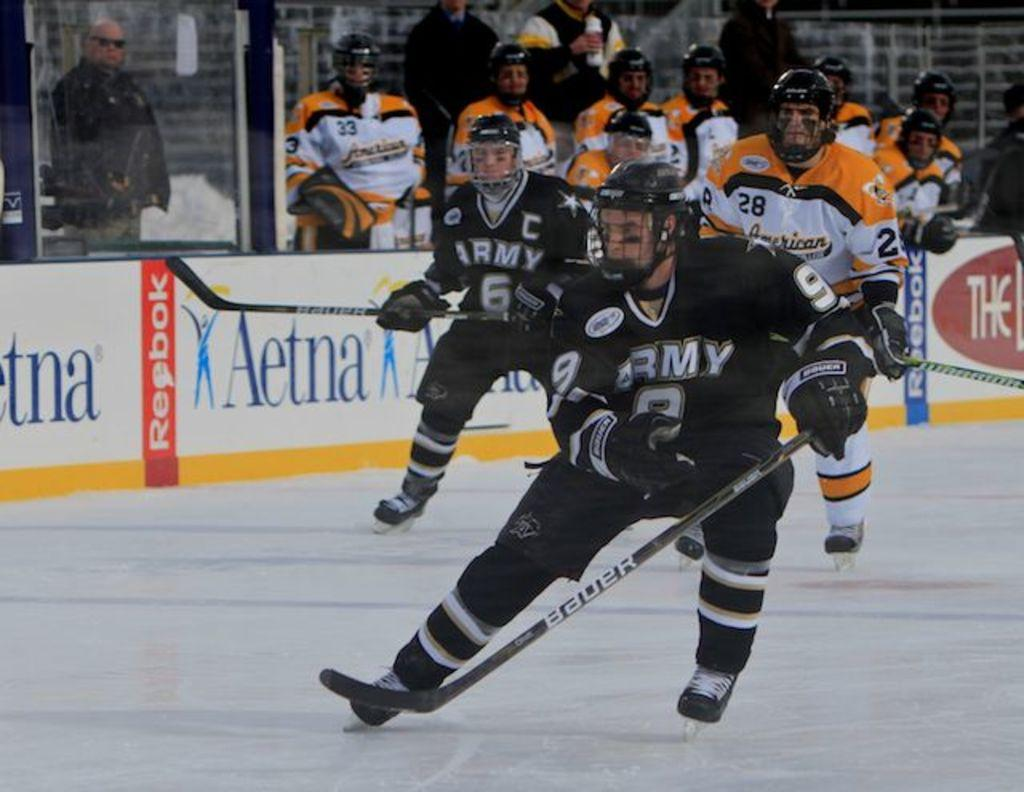Provide a one-sentence caption for the provided image. Hockey players in black uniforms with ARMY in white on the jersey's. 